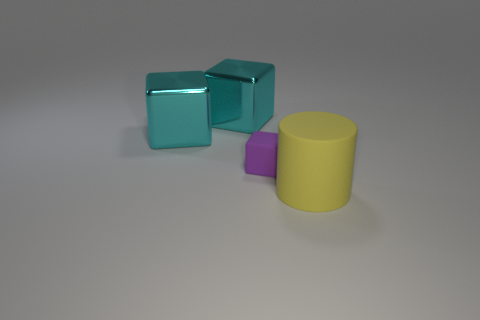What shape is the object that is in front of the tiny purple object? In front of the tiny purple object, there is a yellow cylinder. This cylindrical object's smooth, curved surface contrasts with the angular shapes of the other objects in the image. 